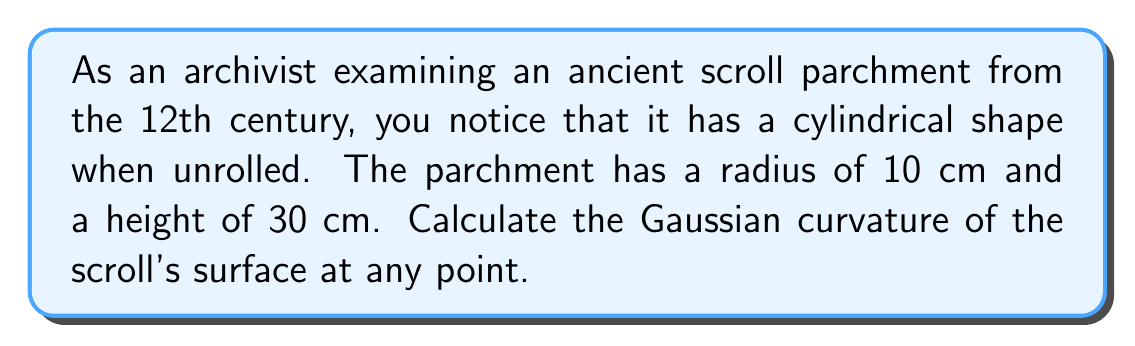Could you help me with this problem? To calculate the Gaussian curvature of the cylindrical scroll surface, we'll follow these steps:

1. Recall that the Gaussian curvature $K$ is the product of the principal curvatures $k_1$ and $k_2$:

   $$K = k_1 \cdot k_2$$

2. For a cylinder, one principal curvature ($k_1$) is the reciprocal of the radius, and the other ($k_2$) is zero:

   $k_1 = \frac{1}{r}$, where $r$ is the radius of the cylinder
   $k_2 = 0$

3. Given the radius of the scroll is 10 cm:

   $k_1 = \frac{1}{10} = 0.1 \text{ cm}^{-1}$
   $k_2 = 0 \text{ cm}^{-1}$

4. Calculate the Gaussian curvature:

   $$K = k_1 \cdot k_2 = 0.1 \cdot 0 = 0 \text{ cm}^{-2}$$

5. The Gaussian curvature is zero at every point on the cylindrical surface.

[asy]
import geometry;

size(200);
real r = 3;
real h = 9;

path3 p = (r,0,0)..(0,r,0)..(-r,0,0)..(0,-r,0)..cycle;
revolution cyl = revolution(p, Z);
draw(surface(cyl), lightgray);
draw(path3(cyl), blue);

draw((r,0,0)--(r,0,h), blue);
draw((0,r,0)--(0,r,h), blue);
draw((-r,0,0)--(-r,0,h), blue);
draw((0,-r,0)--(0,-r,h), blue);

draw(circle((0,0,h), r), blue);

label("$r$", (r/2,r/2,0), E);
label("$h$", (r,0,h/2), E);
[/asy]
Answer: $0 \text{ cm}^{-2}$ 